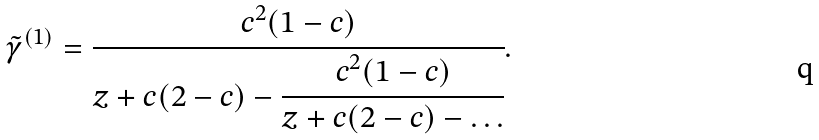Convert formula to latex. <formula><loc_0><loc_0><loc_500><loc_500>\tilde { \gamma } ^ { ( 1 ) } = \cfrac { c ^ { 2 } ( 1 - c ) } { z + c ( 2 - c ) - \cfrac { c ^ { 2 } ( 1 - c ) } { z + c ( 2 - c ) - \dots } } .</formula> 